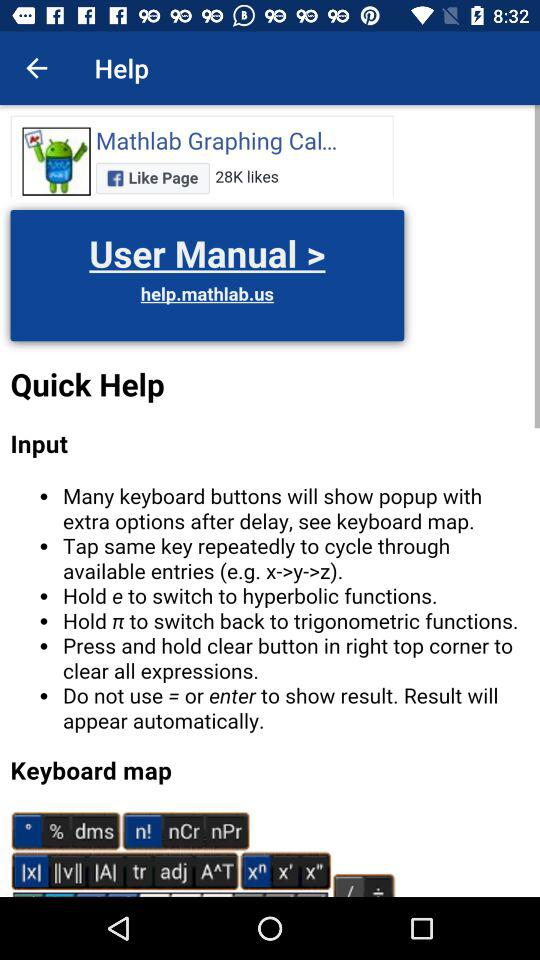What keyboard button should we not use to show the result? You should not use "= or enter". 